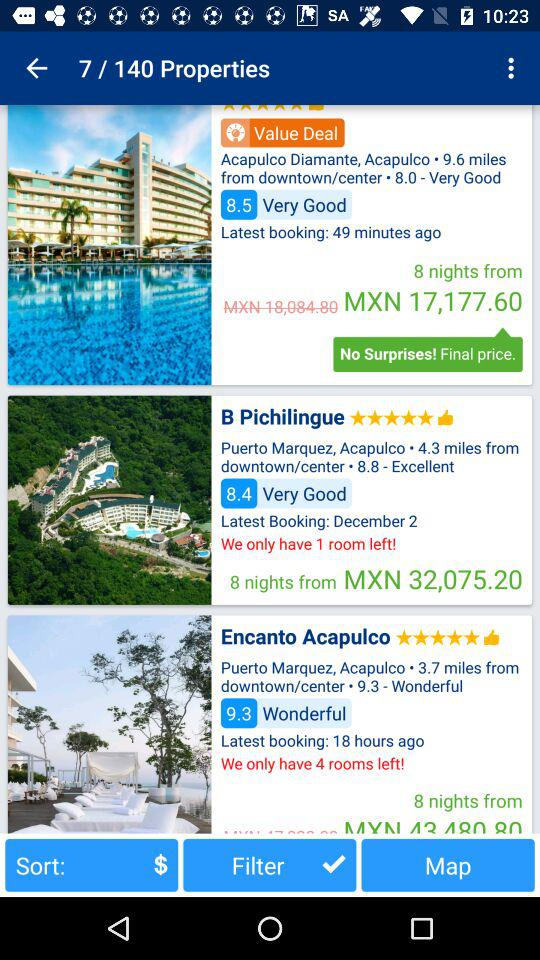How many properties in total are there? There are 140 properties. 